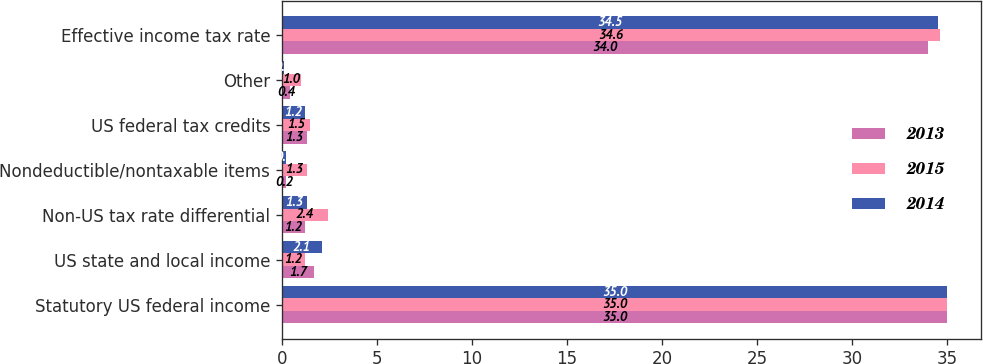<chart> <loc_0><loc_0><loc_500><loc_500><stacked_bar_chart><ecel><fcel>Statutory US federal income<fcel>US state and local income<fcel>Non-US tax rate differential<fcel>Nondeductible/nontaxable items<fcel>US federal tax credits<fcel>Other<fcel>Effective income tax rate<nl><fcel>2013<fcel>35<fcel>1.7<fcel>1.2<fcel>0.2<fcel>1.3<fcel>0.4<fcel>34<nl><fcel>2015<fcel>35<fcel>1.2<fcel>2.4<fcel>1.3<fcel>1.5<fcel>1<fcel>34.6<nl><fcel>2014<fcel>35<fcel>2.1<fcel>1.3<fcel>0.2<fcel>1.2<fcel>0.1<fcel>34.5<nl></chart> 